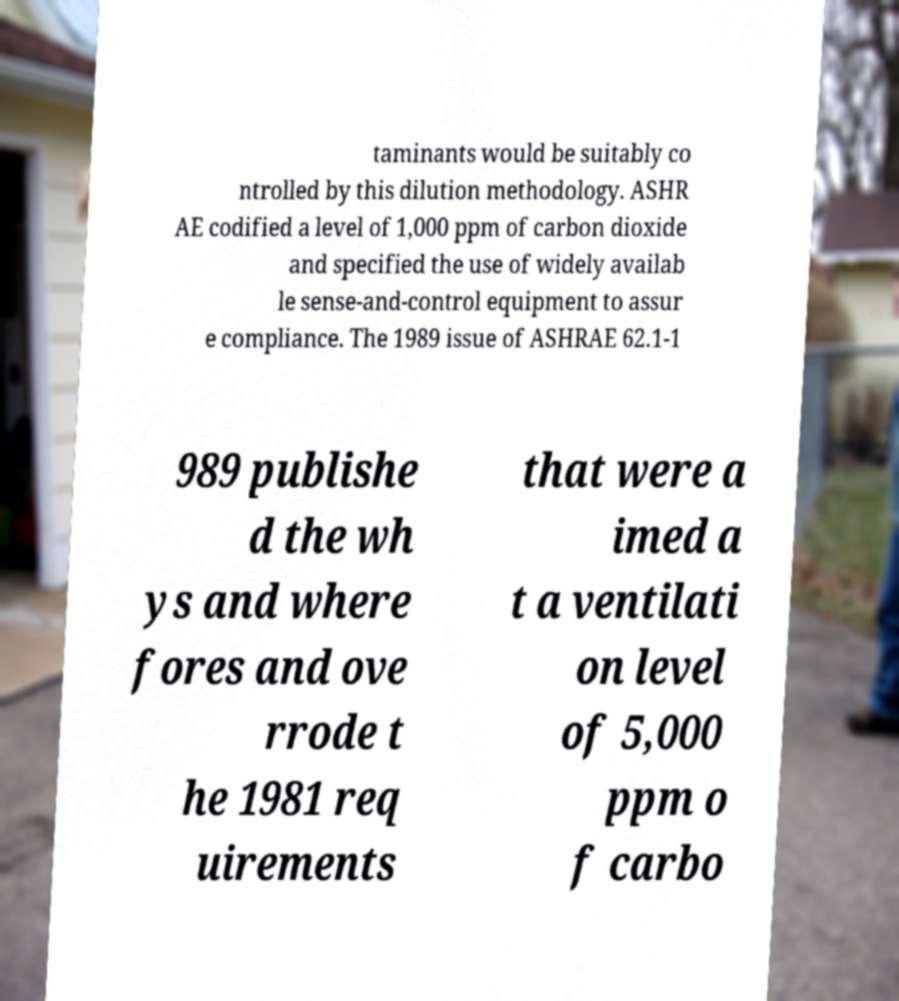There's text embedded in this image that I need extracted. Can you transcribe it verbatim? taminants would be suitably co ntrolled by this dilution methodology. ASHR AE codified a level of 1,000 ppm of carbon dioxide and specified the use of widely availab le sense-and-control equipment to assur e compliance. The 1989 issue of ASHRAE 62.1-1 989 publishe d the wh ys and where fores and ove rrode t he 1981 req uirements that were a imed a t a ventilati on level of 5,000 ppm o f carbo 